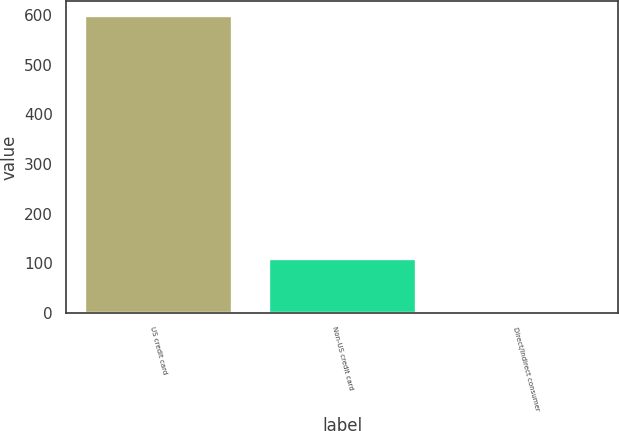<chart> <loc_0><loc_0><loc_500><loc_500><bar_chart><fcel>US credit card<fcel>Non-US credit card<fcel>Direct/Indirect consumer<nl><fcel>598<fcel>109<fcel>3<nl></chart> 